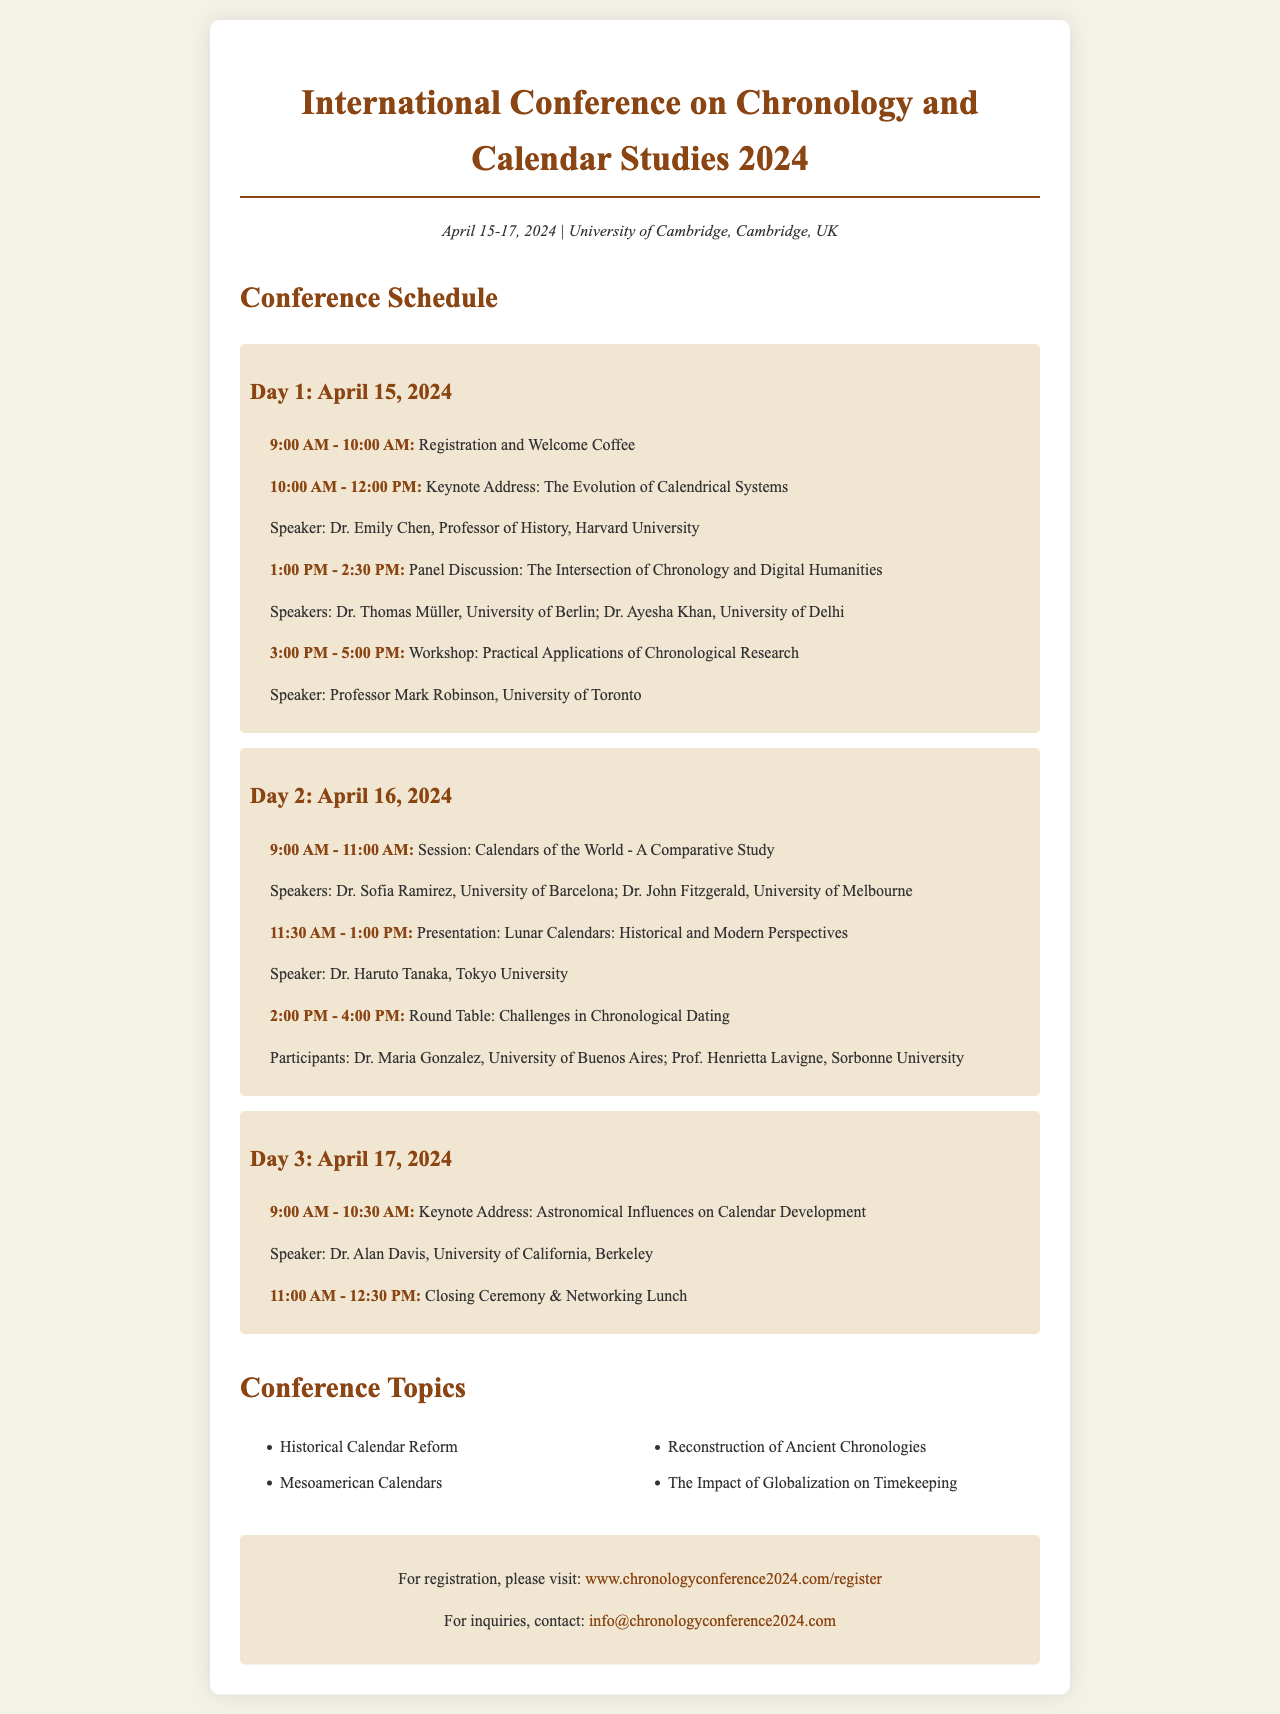What are the dates of the conference? The conference will take place from April 15 to April 17, 2024.
Answer: April 15-17, 2024 Who is the speaker for the keynote address on the first day? The keynote address on the first day features Dr. Emily Chen, Professor of History at Harvard University.
Answer: Dr. Emily Chen What is the location of the conference? The conference will be held at the University of Cambridge, located in Cambridge, UK.
Answer: University of Cambridge, Cambridge, UK What time does registration start on the first day? The registration and welcome coffee start at 9:00 AM on the first day of the conference.
Answer: 9:00 AM Which topic is covered in the panel discussion? The panel discussion focuses on the intersection of chronology and digital humanities.
Answer: The Intersection of Chronology and Digital Humanities How many keynote addresses are scheduled during the conference? There are three keynote addresses scheduled throughout the conference.
Answer: Three Who will present on Lunar Calendars? Dr. Haruto Tanaka from Tokyo University will present on Lunar Calendars.
Answer: Dr. Haruto Tanaka What is one of the topics listed under conference topics? The document lists "Historical Calendar Reform" as one of the topics of discussion.
Answer: Historical Calendar Reform What is the name of the website for conference registration? The registration website mentioned for the conference is www.chronologyconference2024.com/register.
Answer: www.chronologyconference2024.com/register 